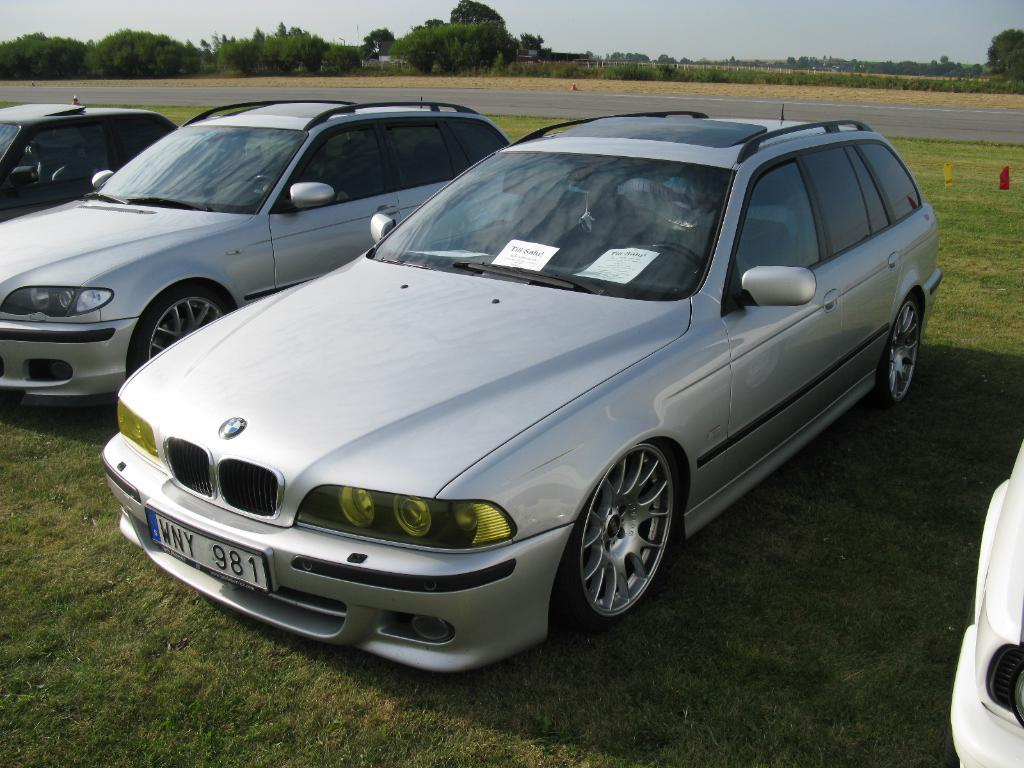What types of vehicles can be seen in the image? There are vehicles in the image, but the specific types are not mentioned. What is the surface on which the vehicles are traveling? There is a road visible in the image. What type of vegetation is present in the image? There are trees in the image. What is the ground covered with in the image? The ground is covered with grass in the image. What can be seen in the background of the image? The sky is visible in the background of the image. What type of silver paste is being used to shock the trees in the image? There is no silver paste or shocking of trees present in the image. 